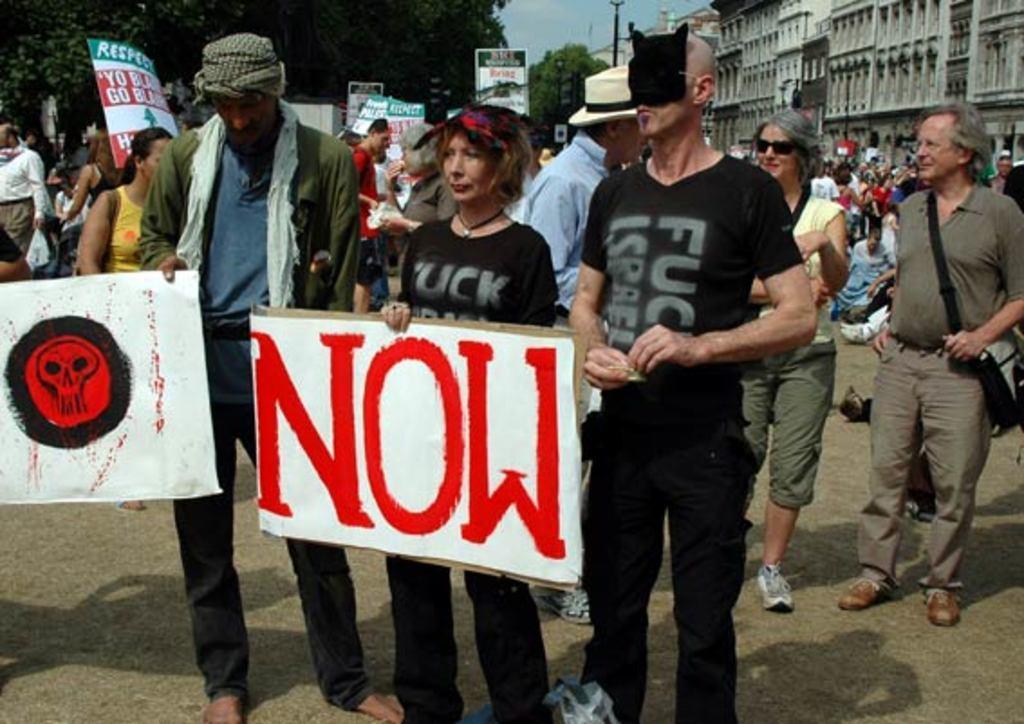How would you summarize this image in a sentence or two? In the image there are three people standing and holding the posters with image and some things written on it. Behind them there are many people standing and also there are holding posters in their hands. In the background there are trees, buildings and also there is a pole. 